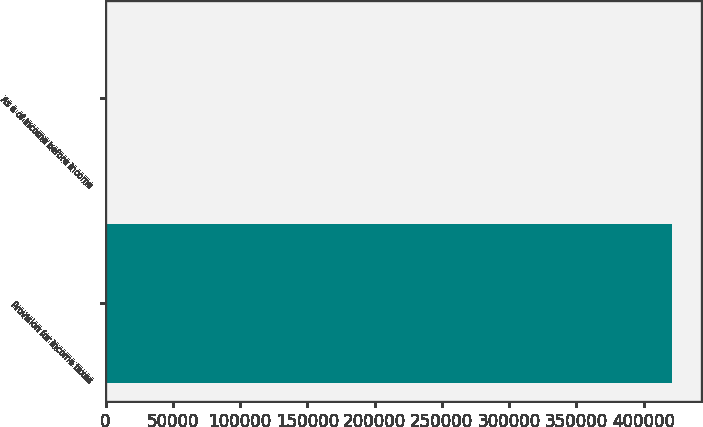Convert chart. <chart><loc_0><loc_0><loc_500><loc_500><bar_chart><fcel>Provision for income taxes<fcel>As a of income before income<nl><fcel>421418<fcel>27<nl></chart> 